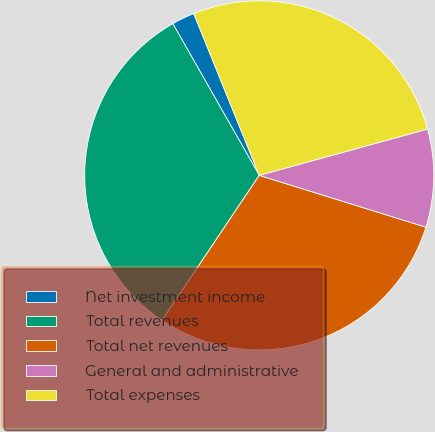Convert chart to OTSL. <chart><loc_0><loc_0><loc_500><loc_500><pie_chart><fcel>Net investment income<fcel>Total revenues<fcel>Total net revenues<fcel>General and administrative<fcel>Total expenses<nl><fcel>2.12%<fcel>32.36%<fcel>29.6%<fcel>9.07%<fcel>26.85%<nl></chart> 